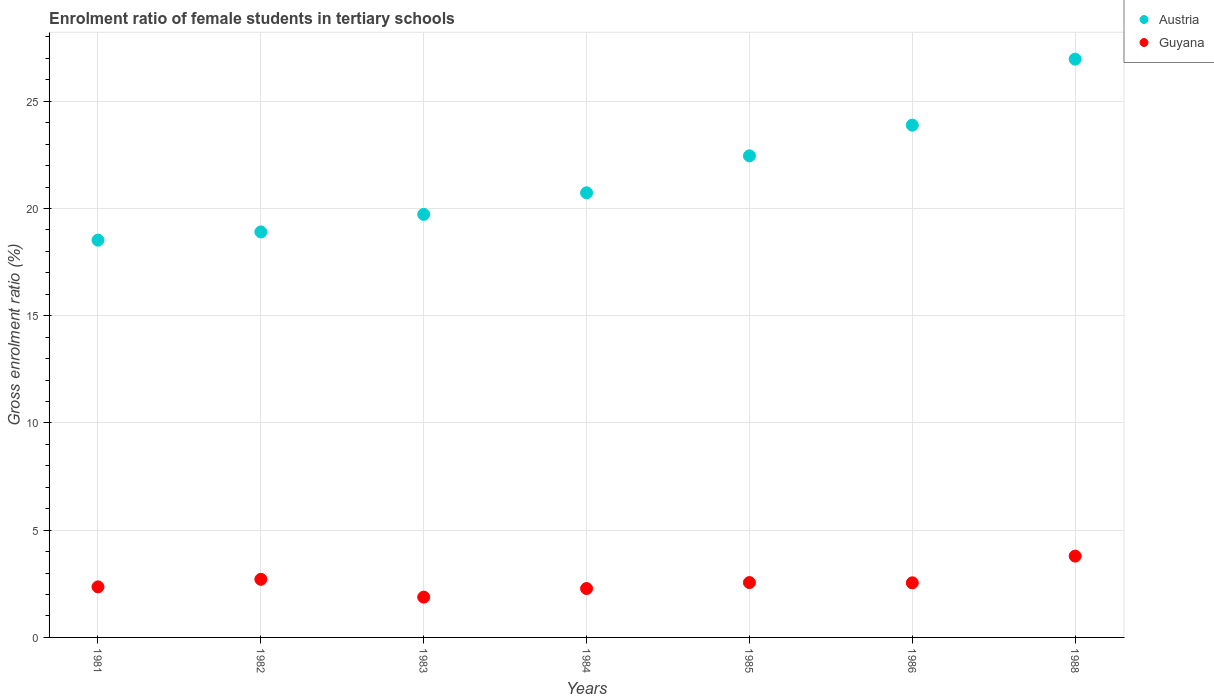How many different coloured dotlines are there?
Provide a short and direct response. 2. What is the enrolment ratio of female students in tertiary schools in Austria in 1983?
Provide a short and direct response. 19.73. Across all years, what is the maximum enrolment ratio of female students in tertiary schools in Austria?
Offer a terse response. 26.97. Across all years, what is the minimum enrolment ratio of female students in tertiary schools in Guyana?
Offer a very short reply. 1.88. In which year was the enrolment ratio of female students in tertiary schools in Guyana minimum?
Provide a short and direct response. 1983. What is the total enrolment ratio of female students in tertiary schools in Guyana in the graph?
Your answer should be very brief. 18.12. What is the difference between the enrolment ratio of female students in tertiary schools in Guyana in 1981 and that in 1984?
Keep it short and to the point. 0.08. What is the difference between the enrolment ratio of female students in tertiary schools in Guyana in 1983 and the enrolment ratio of female students in tertiary schools in Austria in 1982?
Your answer should be compact. -17.03. What is the average enrolment ratio of female students in tertiary schools in Austria per year?
Your answer should be very brief. 21.6. In the year 1988, what is the difference between the enrolment ratio of female students in tertiary schools in Guyana and enrolment ratio of female students in tertiary schools in Austria?
Provide a succinct answer. -23.17. In how many years, is the enrolment ratio of female students in tertiary schools in Guyana greater than 19 %?
Provide a succinct answer. 0. What is the ratio of the enrolment ratio of female students in tertiary schools in Guyana in 1981 to that in 1983?
Offer a terse response. 1.25. Is the enrolment ratio of female students in tertiary schools in Guyana in 1981 less than that in 1982?
Make the answer very short. Yes. Is the difference between the enrolment ratio of female students in tertiary schools in Guyana in 1982 and 1983 greater than the difference between the enrolment ratio of female students in tertiary schools in Austria in 1982 and 1983?
Offer a very short reply. Yes. What is the difference between the highest and the second highest enrolment ratio of female students in tertiary schools in Austria?
Your response must be concise. 3.08. What is the difference between the highest and the lowest enrolment ratio of female students in tertiary schools in Austria?
Ensure brevity in your answer.  8.44. In how many years, is the enrolment ratio of female students in tertiary schools in Guyana greater than the average enrolment ratio of female students in tertiary schools in Guyana taken over all years?
Provide a short and direct response. 2. Is the sum of the enrolment ratio of female students in tertiary schools in Guyana in 1985 and 1986 greater than the maximum enrolment ratio of female students in tertiary schools in Austria across all years?
Offer a terse response. No. Does the enrolment ratio of female students in tertiary schools in Guyana monotonically increase over the years?
Ensure brevity in your answer.  No. Is the enrolment ratio of female students in tertiary schools in Guyana strictly less than the enrolment ratio of female students in tertiary schools in Austria over the years?
Your answer should be compact. Yes. How many dotlines are there?
Offer a very short reply. 2. How many years are there in the graph?
Provide a succinct answer. 7. Does the graph contain any zero values?
Keep it short and to the point. No. How many legend labels are there?
Make the answer very short. 2. What is the title of the graph?
Your answer should be very brief. Enrolment ratio of female students in tertiary schools. Does "Tuvalu" appear as one of the legend labels in the graph?
Give a very brief answer. No. What is the label or title of the X-axis?
Make the answer very short. Years. What is the label or title of the Y-axis?
Offer a very short reply. Gross enrolment ratio (%). What is the Gross enrolment ratio (%) in Austria in 1981?
Provide a short and direct response. 18.53. What is the Gross enrolment ratio (%) in Guyana in 1981?
Keep it short and to the point. 2.36. What is the Gross enrolment ratio (%) in Austria in 1982?
Your answer should be compact. 18.91. What is the Gross enrolment ratio (%) of Guyana in 1982?
Provide a succinct answer. 2.71. What is the Gross enrolment ratio (%) in Austria in 1983?
Make the answer very short. 19.73. What is the Gross enrolment ratio (%) of Guyana in 1983?
Offer a very short reply. 1.88. What is the Gross enrolment ratio (%) of Austria in 1984?
Your response must be concise. 20.73. What is the Gross enrolment ratio (%) of Guyana in 1984?
Your response must be concise. 2.28. What is the Gross enrolment ratio (%) of Austria in 1985?
Offer a very short reply. 22.46. What is the Gross enrolment ratio (%) of Guyana in 1985?
Make the answer very short. 2.56. What is the Gross enrolment ratio (%) in Austria in 1986?
Provide a short and direct response. 23.89. What is the Gross enrolment ratio (%) in Guyana in 1986?
Your answer should be compact. 2.55. What is the Gross enrolment ratio (%) in Austria in 1988?
Offer a terse response. 26.97. What is the Gross enrolment ratio (%) in Guyana in 1988?
Your answer should be compact. 3.79. Across all years, what is the maximum Gross enrolment ratio (%) in Austria?
Offer a terse response. 26.97. Across all years, what is the maximum Gross enrolment ratio (%) of Guyana?
Provide a succinct answer. 3.79. Across all years, what is the minimum Gross enrolment ratio (%) of Austria?
Ensure brevity in your answer.  18.53. Across all years, what is the minimum Gross enrolment ratio (%) of Guyana?
Offer a terse response. 1.88. What is the total Gross enrolment ratio (%) in Austria in the graph?
Keep it short and to the point. 151.21. What is the total Gross enrolment ratio (%) in Guyana in the graph?
Provide a succinct answer. 18.12. What is the difference between the Gross enrolment ratio (%) of Austria in 1981 and that in 1982?
Ensure brevity in your answer.  -0.38. What is the difference between the Gross enrolment ratio (%) of Guyana in 1981 and that in 1982?
Keep it short and to the point. -0.35. What is the difference between the Gross enrolment ratio (%) of Austria in 1981 and that in 1983?
Offer a terse response. -1.2. What is the difference between the Gross enrolment ratio (%) of Guyana in 1981 and that in 1983?
Your response must be concise. 0.48. What is the difference between the Gross enrolment ratio (%) of Austria in 1981 and that in 1984?
Your answer should be very brief. -2.21. What is the difference between the Gross enrolment ratio (%) of Guyana in 1981 and that in 1984?
Your answer should be very brief. 0.08. What is the difference between the Gross enrolment ratio (%) in Austria in 1981 and that in 1985?
Offer a terse response. -3.93. What is the difference between the Gross enrolment ratio (%) of Guyana in 1981 and that in 1985?
Make the answer very short. -0.2. What is the difference between the Gross enrolment ratio (%) in Austria in 1981 and that in 1986?
Ensure brevity in your answer.  -5.36. What is the difference between the Gross enrolment ratio (%) of Guyana in 1981 and that in 1986?
Offer a very short reply. -0.19. What is the difference between the Gross enrolment ratio (%) in Austria in 1981 and that in 1988?
Make the answer very short. -8.44. What is the difference between the Gross enrolment ratio (%) of Guyana in 1981 and that in 1988?
Offer a very short reply. -1.44. What is the difference between the Gross enrolment ratio (%) in Austria in 1982 and that in 1983?
Provide a succinct answer. -0.82. What is the difference between the Gross enrolment ratio (%) of Guyana in 1982 and that in 1983?
Your answer should be very brief. 0.83. What is the difference between the Gross enrolment ratio (%) in Austria in 1982 and that in 1984?
Make the answer very short. -1.82. What is the difference between the Gross enrolment ratio (%) of Guyana in 1982 and that in 1984?
Make the answer very short. 0.43. What is the difference between the Gross enrolment ratio (%) of Austria in 1982 and that in 1985?
Offer a very short reply. -3.55. What is the difference between the Gross enrolment ratio (%) in Guyana in 1982 and that in 1985?
Your answer should be very brief. 0.15. What is the difference between the Gross enrolment ratio (%) of Austria in 1982 and that in 1986?
Give a very brief answer. -4.98. What is the difference between the Gross enrolment ratio (%) in Guyana in 1982 and that in 1986?
Provide a short and direct response. 0.16. What is the difference between the Gross enrolment ratio (%) of Austria in 1982 and that in 1988?
Your response must be concise. -8.06. What is the difference between the Gross enrolment ratio (%) in Guyana in 1982 and that in 1988?
Your answer should be compact. -1.08. What is the difference between the Gross enrolment ratio (%) in Austria in 1983 and that in 1984?
Your answer should be compact. -1.01. What is the difference between the Gross enrolment ratio (%) in Guyana in 1983 and that in 1984?
Make the answer very short. -0.4. What is the difference between the Gross enrolment ratio (%) of Austria in 1983 and that in 1985?
Make the answer very short. -2.73. What is the difference between the Gross enrolment ratio (%) of Guyana in 1983 and that in 1985?
Offer a terse response. -0.68. What is the difference between the Gross enrolment ratio (%) of Austria in 1983 and that in 1986?
Offer a very short reply. -4.16. What is the difference between the Gross enrolment ratio (%) of Guyana in 1983 and that in 1986?
Keep it short and to the point. -0.67. What is the difference between the Gross enrolment ratio (%) of Austria in 1983 and that in 1988?
Your response must be concise. -7.24. What is the difference between the Gross enrolment ratio (%) in Guyana in 1983 and that in 1988?
Ensure brevity in your answer.  -1.91. What is the difference between the Gross enrolment ratio (%) of Austria in 1984 and that in 1985?
Your response must be concise. -1.72. What is the difference between the Gross enrolment ratio (%) in Guyana in 1984 and that in 1985?
Provide a succinct answer. -0.28. What is the difference between the Gross enrolment ratio (%) in Austria in 1984 and that in 1986?
Make the answer very short. -3.15. What is the difference between the Gross enrolment ratio (%) of Guyana in 1984 and that in 1986?
Your answer should be compact. -0.27. What is the difference between the Gross enrolment ratio (%) of Austria in 1984 and that in 1988?
Offer a very short reply. -6.23. What is the difference between the Gross enrolment ratio (%) of Guyana in 1984 and that in 1988?
Keep it short and to the point. -1.51. What is the difference between the Gross enrolment ratio (%) of Austria in 1985 and that in 1986?
Ensure brevity in your answer.  -1.43. What is the difference between the Gross enrolment ratio (%) in Guyana in 1985 and that in 1986?
Your answer should be very brief. 0.01. What is the difference between the Gross enrolment ratio (%) in Austria in 1985 and that in 1988?
Ensure brevity in your answer.  -4.51. What is the difference between the Gross enrolment ratio (%) in Guyana in 1985 and that in 1988?
Keep it short and to the point. -1.23. What is the difference between the Gross enrolment ratio (%) in Austria in 1986 and that in 1988?
Provide a succinct answer. -3.08. What is the difference between the Gross enrolment ratio (%) of Guyana in 1986 and that in 1988?
Offer a very short reply. -1.25. What is the difference between the Gross enrolment ratio (%) of Austria in 1981 and the Gross enrolment ratio (%) of Guyana in 1982?
Ensure brevity in your answer.  15.82. What is the difference between the Gross enrolment ratio (%) in Austria in 1981 and the Gross enrolment ratio (%) in Guyana in 1983?
Your answer should be very brief. 16.65. What is the difference between the Gross enrolment ratio (%) of Austria in 1981 and the Gross enrolment ratio (%) of Guyana in 1984?
Your answer should be very brief. 16.25. What is the difference between the Gross enrolment ratio (%) in Austria in 1981 and the Gross enrolment ratio (%) in Guyana in 1985?
Make the answer very short. 15.97. What is the difference between the Gross enrolment ratio (%) of Austria in 1981 and the Gross enrolment ratio (%) of Guyana in 1986?
Ensure brevity in your answer.  15.98. What is the difference between the Gross enrolment ratio (%) of Austria in 1981 and the Gross enrolment ratio (%) of Guyana in 1988?
Your answer should be compact. 14.73. What is the difference between the Gross enrolment ratio (%) in Austria in 1982 and the Gross enrolment ratio (%) in Guyana in 1983?
Give a very brief answer. 17.03. What is the difference between the Gross enrolment ratio (%) of Austria in 1982 and the Gross enrolment ratio (%) of Guyana in 1984?
Provide a short and direct response. 16.63. What is the difference between the Gross enrolment ratio (%) of Austria in 1982 and the Gross enrolment ratio (%) of Guyana in 1985?
Offer a terse response. 16.35. What is the difference between the Gross enrolment ratio (%) in Austria in 1982 and the Gross enrolment ratio (%) in Guyana in 1986?
Make the answer very short. 16.36. What is the difference between the Gross enrolment ratio (%) in Austria in 1982 and the Gross enrolment ratio (%) in Guyana in 1988?
Keep it short and to the point. 15.12. What is the difference between the Gross enrolment ratio (%) of Austria in 1983 and the Gross enrolment ratio (%) of Guyana in 1984?
Ensure brevity in your answer.  17.45. What is the difference between the Gross enrolment ratio (%) in Austria in 1983 and the Gross enrolment ratio (%) in Guyana in 1985?
Give a very brief answer. 17.17. What is the difference between the Gross enrolment ratio (%) in Austria in 1983 and the Gross enrolment ratio (%) in Guyana in 1986?
Provide a short and direct response. 17.18. What is the difference between the Gross enrolment ratio (%) of Austria in 1983 and the Gross enrolment ratio (%) of Guyana in 1988?
Your answer should be compact. 15.93. What is the difference between the Gross enrolment ratio (%) in Austria in 1984 and the Gross enrolment ratio (%) in Guyana in 1985?
Provide a succinct answer. 18.18. What is the difference between the Gross enrolment ratio (%) in Austria in 1984 and the Gross enrolment ratio (%) in Guyana in 1986?
Your answer should be compact. 18.19. What is the difference between the Gross enrolment ratio (%) in Austria in 1984 and the Gross enrolment ratio (%) in Guyana in 1988?
Keep it short and to the point. 16.94. What is the difference between the Gross enrolment ratio (%) of Austria in 1985 and the Gross enrolment ratio (%) of Guyana in 1986?
Provide a short and direct response. 19.91. What is the difference between the Gross enrolment ratio (%) of Austria in 1985 and the Gross enrolment ratio (%) of Guyana in 1988?
Offer a terse response. 18.67. What is the difference between the Gross enrolment ratio (%) in Austria in 1986 and the Gross enrolment ratio (%) in Guyana in 1988?
Ensure brevity in your answer.  20.1. What is the average Gross enrolment ratio (%) of Austria per year?
Give a very brief answer. 21.6. What is the average Gross enrolment ratio (%) in Guyana per year?
Provide a succinct answer. 2.59. In the year 1981, what is the difference between the Gross enrolment ratio (%) of Austria and Gross enrolment ratio (%) of Guyana?
Your answer should be compact. 16.17. In the year 1982, what is the difference between the Gross enrolment ratio (%) in Austria and Gross enrolment ratio (%) in Guyana?
Your answer should be very brief. 16.2. In the year 1983, what is the difference between the Gross enrolment ratio (%) in Austria and Gross enrolment ratio (%) in Guyana?
Provide a succinct answer. 17.85. In the year 1984, what is the difference between the Gross enrolment ratio (%) of Austria and Gross enrolment ratio (%) of Guyana?
Provide a succinct answer. 18.45. In the year 1985, what is the difference between the Gross enrolment ratio (%) in Austria and Gross enrolment ratio (%) in Guyana?
Ensure brevity in your answer.  19.9. In the year 1986, what is the difference between the Gross enrolment ratio (%) of Austria and Gross enrolment ratio (%) of Guyana?
Provide a succinct answer. 21.34. In the year 1988, what is the difference between the Gross enrolment ratio (%) of Austria and Gross enrolment ratio (%) of Guyana?
Provide a short and direct response. 23.17. What is the ratio of the Gross enrolment ratio (%) of Austria in 1981 to that in 1982?
Keep it short and to the point. 0.98. What is the ratio of the Gross enrolment ratio (%) of Guyana in 1981 to that in 1982?
Provide a short and direct response. 0.87. What is the ratio of the Gross enrolment ratio (%) in Austria in 1981 to that in 1983?
Your response must be concise. 0.94. What is the ratio of the Gross enrolment ratio (%) of Guyana in 1981 to that in 1983?
Keep it short and to the point. 1.25. What is the ratio of the Gross enrolment ratio (%) of Austria in 1981 to that in 1984?
Your answer should be compact. 0.89. What is the ratio of the Gross enrolment ratio (%) in Guyana in 1981 to that in 1984?
Make the answer very short. 1.03. What is the ratio of the Gross enrolment ratio (%) in Austria in 1981 to that in 1985?
Provide a succinct answer. 0.82. What is the ratio of the Gross enrolment ratio (%) of Guyana in 1981 to that in 1985?
Offer a very short reply. 0.92. What is the ratio of the Gross enrolment ratio (%) in Austria in 1981 to that in 1986?
Offer a very short reply. 0.78. What is the ratio of the Gross enrolment ratio (%) in Guyana in 1981 to that in 1986?
Offer a terse response. 0.93. What is the ratio of the Gross enrolment ratio (%) in Austria in 1981 to that in 1988?
Your response must be concise. 0.69. What is the ratio of the Gross enrolment ratio (%) of Guyana in 1981 to that in 1988?
Provide a short and direct response. 0.62. What is the ratio of the Gross enrolment ratio (%) in Austria in 1982 to that in 1983?
Ensure brevity in your answer.  0.96. What is the ratio of the Gross enrolment ratio (%) in Guyana in 1982 to that in 1983?
Give a very brief answer. 1.44. What is the ratio of the Gross enrolment ratio (%) of Austria in 1982 to that in 1984?
Offer a terse response. 0.91. What is the ratio of the Gross enrolment ratio (%) of Guyana in 1982 to that in 1984?
Offer a terse response. 1.19. What is the ratio of the Gross enrolment ratio (%) of Austria in 1982 to that in 1985?
Provide a succinct answer. 0.84. What is the ratio of the Gross enrolment ratio (%) in Guyana in 1982 to that in 1985?
Ensure brevity in your answer.  1.06. What is the ratio of the Gross enrolment ratio (%) in Austria in 1982 to that in 1986?
Offer a very short reply. 0.79. What is the ratio of the Gross enrolment ratio (%) in Guyana in 1982 to that in 1986?
Your answer should be very brief. 1.06. What is the ratio of the Gross enrolment ratio (%) in Austria in 1982 to that in 1988?
Give a very brief answer. 0.7. What is the ratio of the Gross enrolment ratio (%) of Guyana in 1982 to that in 1988?
Provide a succinct answer. 0.71. What is the ratio of the Gross enrolment ratio (%) in Austria in 1983 to that in 1984?
Offer a terse response. 0.95. What is the ratio of the Gross enrolment ratio (%) in Guyana in 1983 to that in 1984?
Provide a short and direct response. 0.82. What is the ratio of the Gross enrolment ratio (%) in Austria in 1983 to that in 1985?
Offer a very short reply. 0.88. What is the ratio of the Gross enrolment ratio (%) of Guyana in 1983 to that in 1985?
Offer a very short reply. 0.73. What is the ratio of the Gross enrolment ratio (%) in Austria in 1983 to that in 1986?
Give a very brief answer. 0.83. What is the ratio of the Gross enrolment ratio (%) of Guyana in 1983 to that in 1986?
Make the answer very short. 0.74. What is the ratio of the Gross enrolment ratio (%) of Austria in 1983 to that in 1988?
Offer a terse response. 0.73. What is the ratio of the Gross enrolment ratio (%) of Guyana in 1983 to that in 1988?
Keep it short and to the point. 0.5. What is the ratio of the Gross enrolment ratio (%) of Austria in 1984 to that in 1985?
Your answer should be very brief. 0.92. What is the ratio of the Gross enrolment ratio (%) in Guyana in 1984 to that in 1985?
Provide a succinct answer. 0.89. What is the ratio of the Gross enrolment ratio (%) in Austria in 1984 to that in 1986?
Keep it short and to the point. 0.87. What is the ratio of the Gross enrolment ratio (%) in Guyana in 1984 to that in 1986?
Provide a succinct answer. 0.9. What is the ratio of the Gross enrolment ratio (%) of Austria in 1984 to that in 1988?
Keep it short and to the point. 0.77. What is the ratio of the Gross enrolment ratio (%) of Guyana in 1984 to that in 1988?
Provide a short and direct response. 0.6. What is the ratio of the Gross enrolment ratio (%) in Austria in 1985 to that in 1986?
Keep it short and to the point. 0.94. What is the ratio of the Gross enrolment ratio (%) in Austria in 1985 to that in 1988?
Offer a terse response. 0.83. What is the ratio of the Gross enrolment ratio (%) of Guyana in 1985 to that in 1988?
Give a very brief answer. 0.67. What is the ratio of the Gross enrolment ratio (%) in Austria in 1986 to that in 1988?
Ensure brevity in your answer.  0.89. What is the ratio of the Gross enrolment ratio (%) in Guyana in 1986 to that in 1988?
Make the answer very short. 0.67. What is the difference between the highest and the second highest Gross enrolment ratio (%) of Austria?
Your response must be concise. 3.08. What is the difference between the highest and the second highest Gross enrolment ratio (%) of Guyana?
Ensure brevity in your answer.  1.08. What is the difference between the highest and the lowest Gross enrolment ratio (%) in Austria?
Your answer should be very brief. 8.44. What is the difference between the highest and the lowest Gross enrolment ratio (%) in Guyana?
Provide a succinct answer. 1.91. 